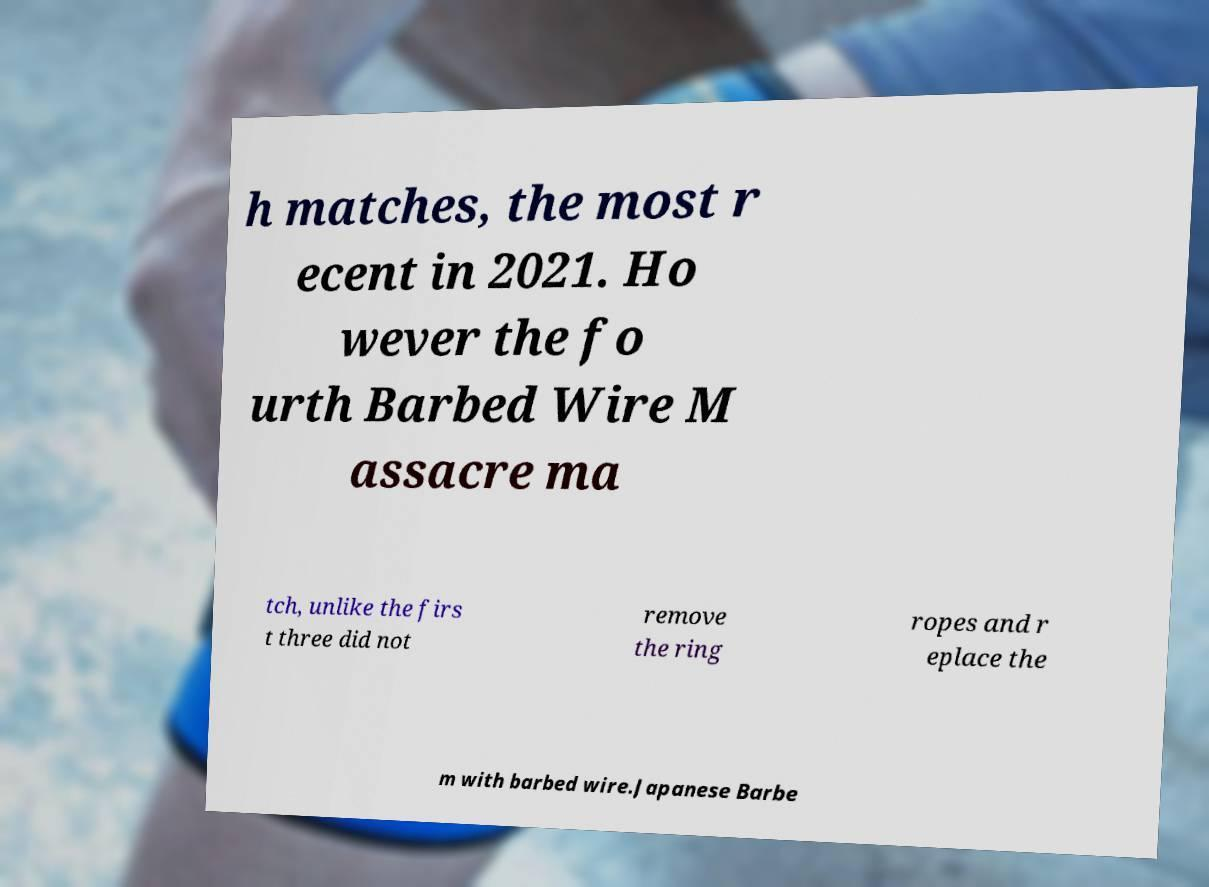Could you extract and type out the text from this image? h matches, the most r ecent in 2021. Ho wever the fo urth Barbed Wire M assacre ma tch, unlike the firs t three did not remove the ring ropes and r eplace the m with barbed wire.Japanese Barbe 